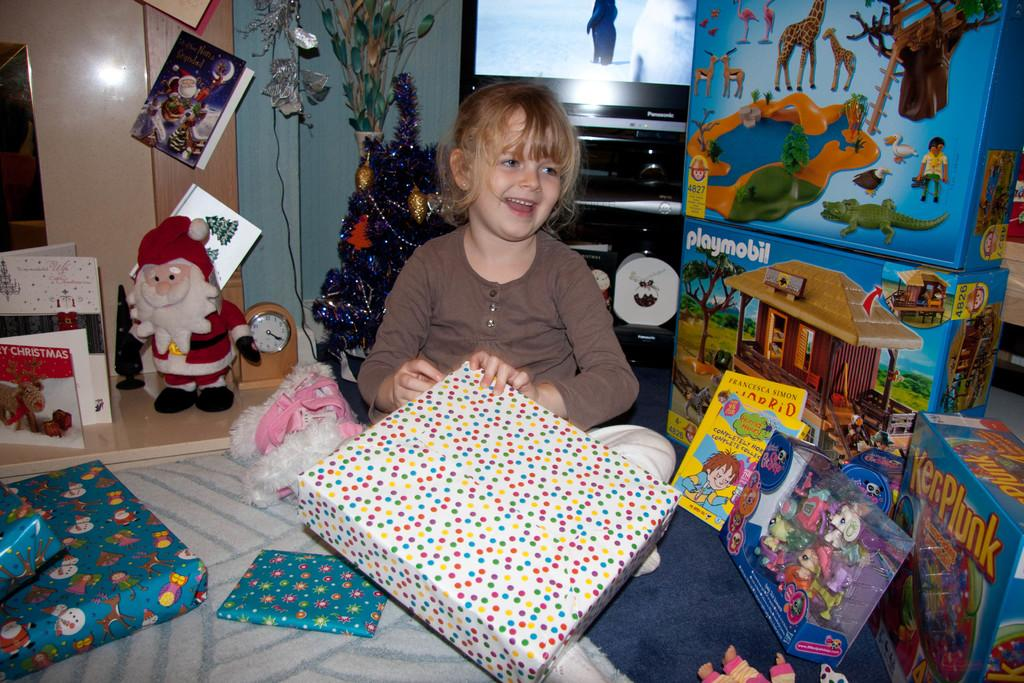Who is in the picture? There is a girl in the picture. What is the girl doing in the picture? The girl is sitting on the bed. What is the girl holding in the picture? The girl is holding a gift box. Can you describe the objects on the left-hand side of the image? There are objects on the left-hand side of the image, but their specific details are not mentioned in the facts. Can you describe the objects on the right-hand side of the image? There are objects on the right-hand side of the image, but their specific details are not mentioned in the facts. What can be seen in the background of the image? There is a television in the background of the image. What type of sand can be seen on the girl's mouth in the image? There is no sand or mouth visible in the image; the girl is holding a gift box and sitting on the bed. 